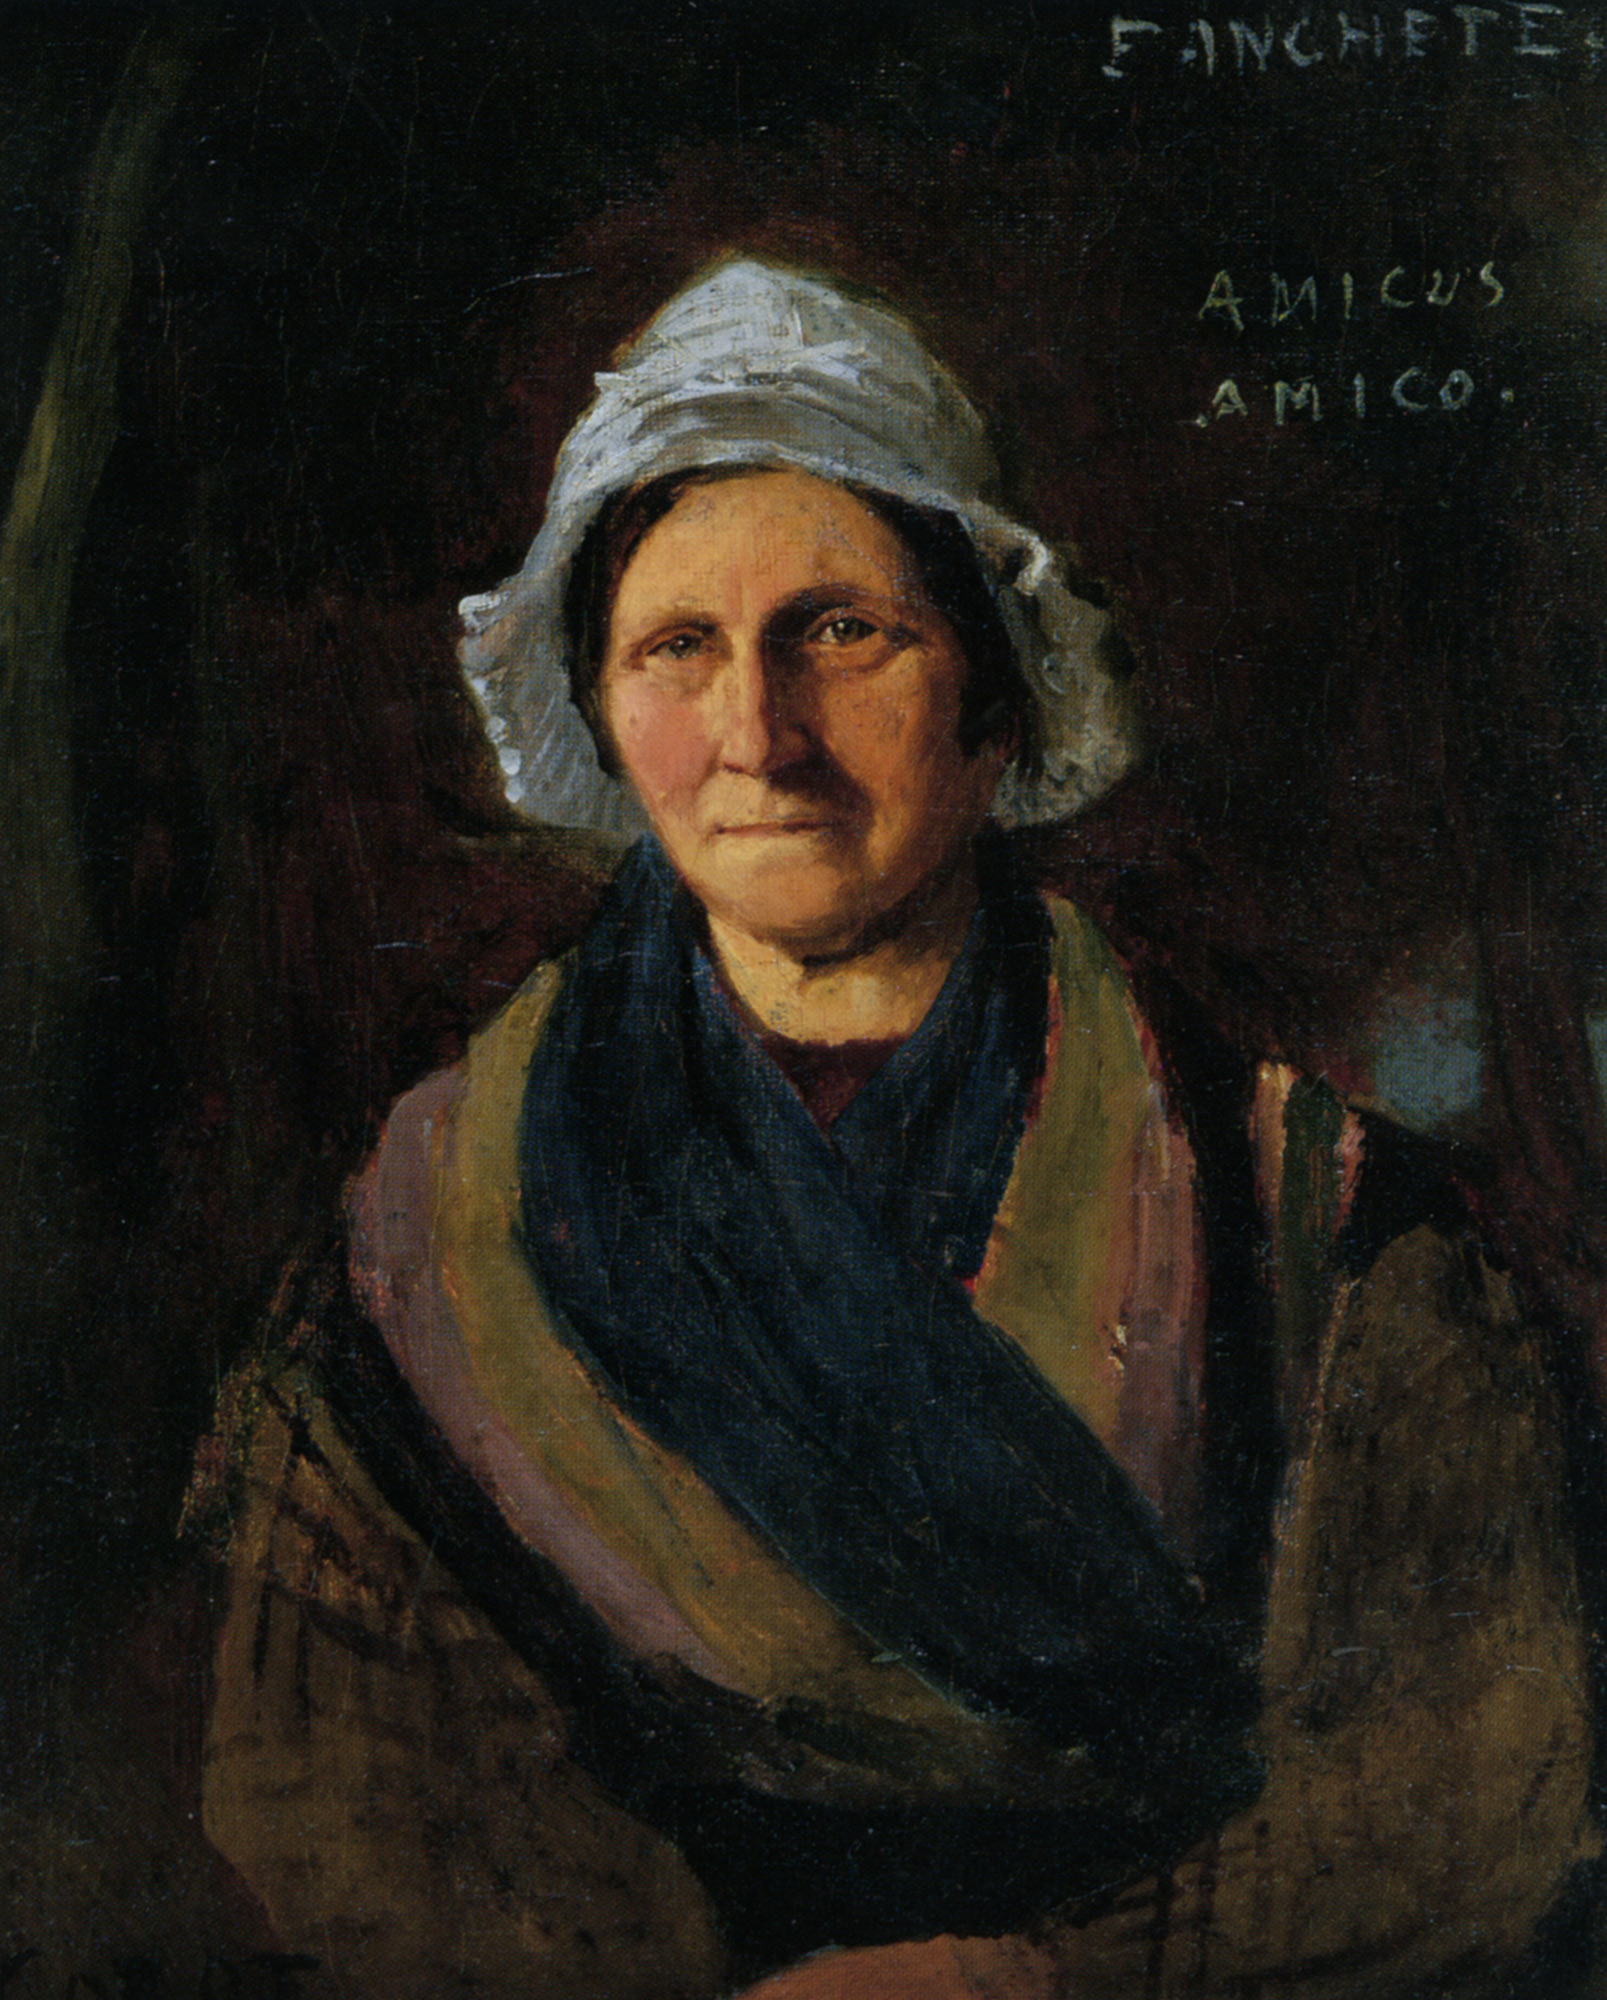What can be deduced about the time period of the painting based on the woman’s attire and the painting style? The woman's attire, with its traditional bonnet and shawl, along with the realistic, somewhat somber style of painting suggests the work might belong to the 19th century. This time period was known for its detailed yet restrained realist paintings, often focusing on the dignified representation of individuals from different walks of life. The clothing style and the subdued color palette further emphasize the norms and artistic trends of that era. 